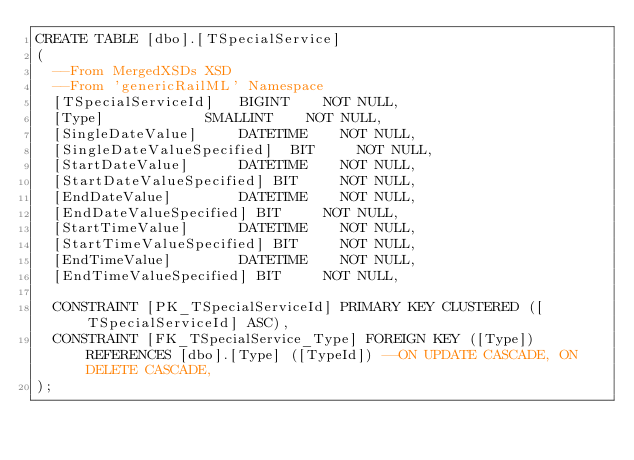Convert code to text. <code><loc_0><loc_0><loc_500><loc_500><_SQL_>CREATE TABLE [dbo].[TSpecialService]
(
	--From MergedXSDs XSD
	--From 'genericRailML' Namespace
	[TSpecialServiceId]		BIGINT		NOT NULL,
	[Type]						SMALLINT		NOT NULL,
	[SingleDateValue]			DATETIME		NOT NULL,
	[SingleDateValueSpecified]	BIT			NOT NULL,
	[StartDateValue]			DATETIME		NOT NULL,
	[StartDateValueSpecified]	BIT			NOT NULL,
	[EndDateValue]				DATETIME		NOT NULL,
	[EndDateValueSpecified]	BIT			NOT NULL,
	[StartTimeValue]			DATETIME		NOT NULL,
	[StartTimeValueSpecified]	BIT			NOT NULL,
	[EndTimeValue]				DATETIME		NOT NULL,
	[EndTimeValueSpecified]	BIT			NOT NULL,

	CONSTRAINT [PK_TSpecialServiceId] PRIMARY KEY CLUSTERED ([TSpecialServiceId] ASC),
	CONSTRAINT [FK_TSpecialService_Type] FOREIGN KEY ([Type]) REFERENCES [dbo].[Type] ([TypeId]) --ON UPDATE CASCADE, ON DELETE CASCADE,
);
</code> 